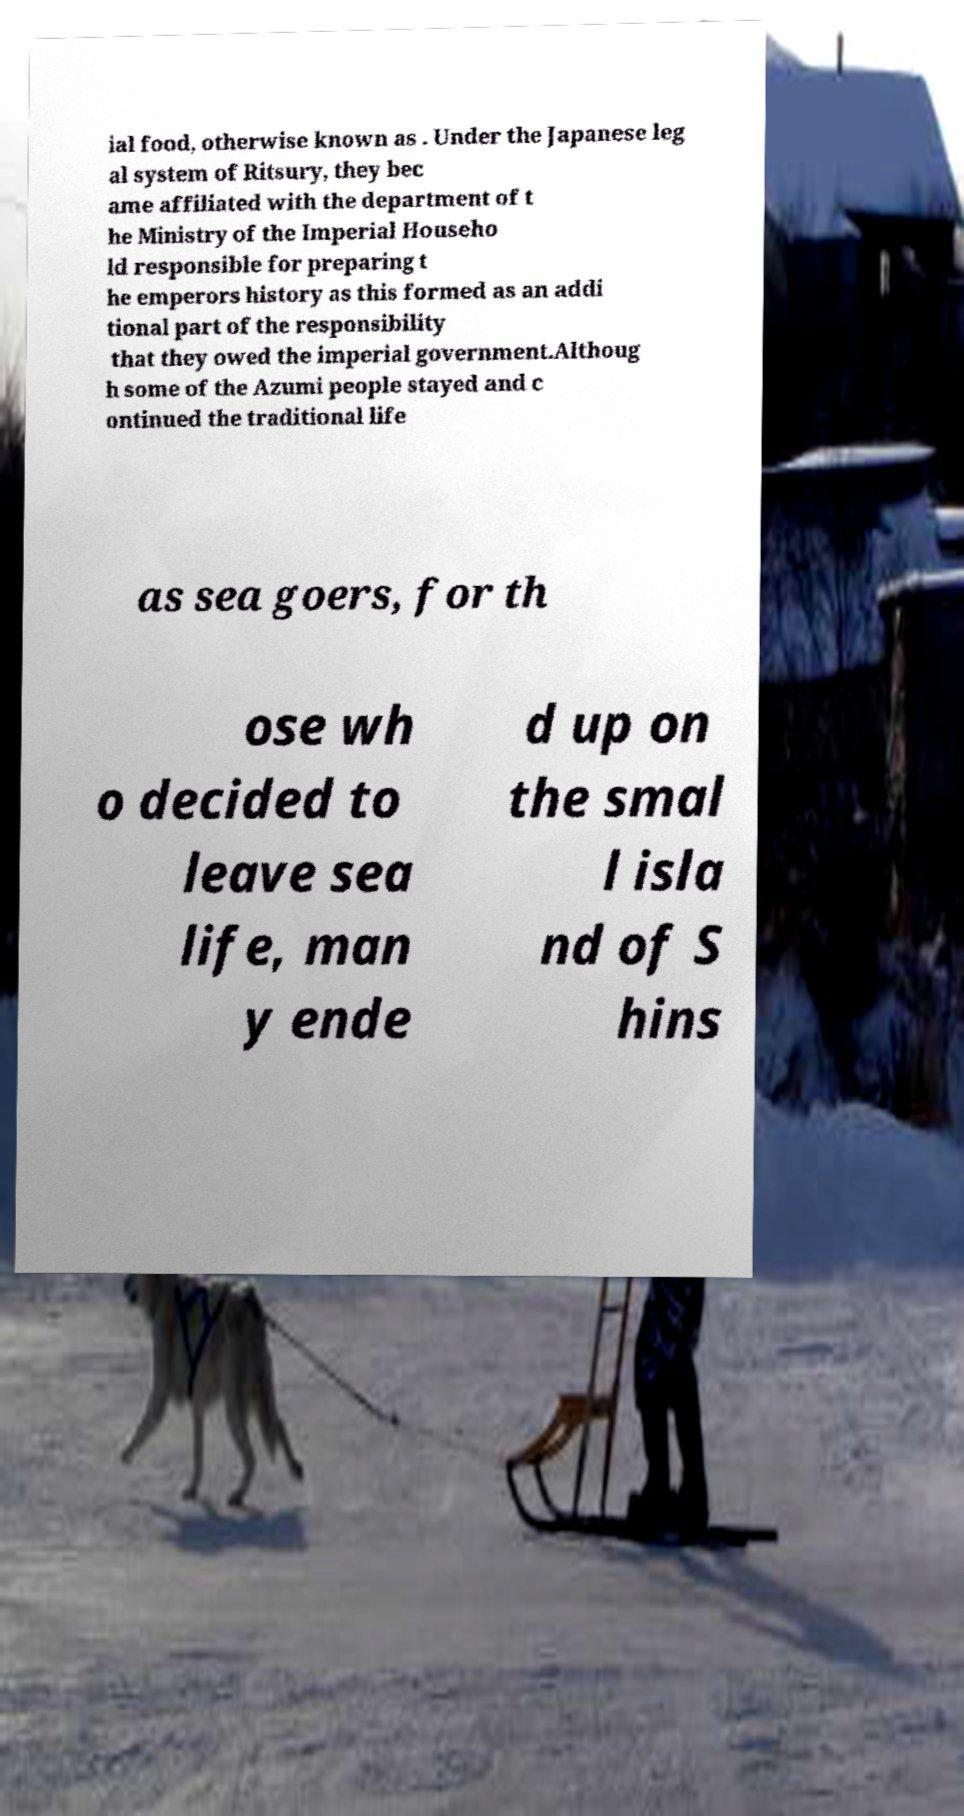Can you accurately transcribe the text from the provided image for me? ial food, otherwise known as . Under the Japanese leg al system of Ritsury, they bec ame affiliated with the department of t he Ministry of the Imperial Househo ld responsible for preparing t he emperors history as this formed as an addi tional part of the responsibility that they owed the imperial government.Althoug h some of the Azumi people stayed and c ontinued the traditional life as sea goers, for th ose wh o decided to leave sea life, man y ende d up on the smal l isla nd of S hins 